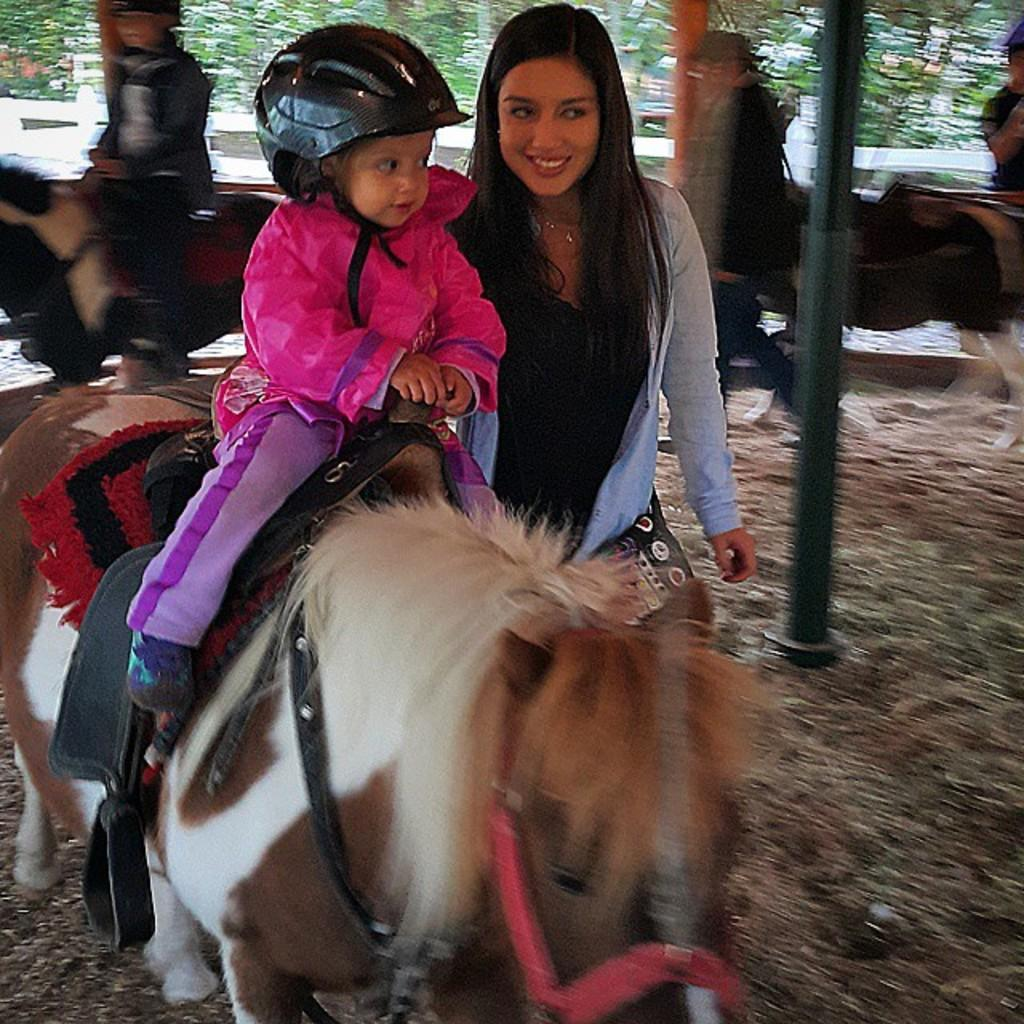Who is present in the image? There is a kid and a woman in the image. What are the kid and woman doing in the image? The kid and woman are sitting on a horse. What can be seen in the background of the image? There is a pole, a man walking, a tree, and a road in the background of the image. What type of horn can be seen on the horse in the image? There is no horn visible on the horse in the image. What color is the smoke coming from the land in the image? There is no smoke or land present in the image. 